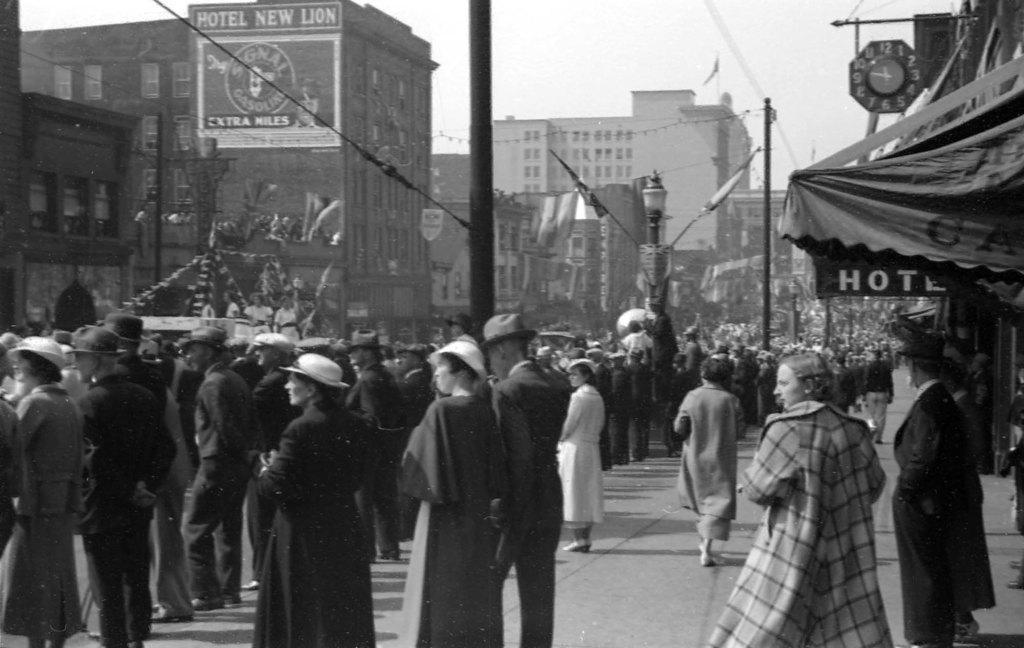Could you give a brief overview of what you see in this image? In the image we can see the black and white picture of the people walking and some of them are standing, they are wearing clothes and some of them are wearing caps. Here we can see the footpath, poles and electric wires. We can even see there are buildings and windows of the building. Here we can see the clock, poster, text and the sky. 